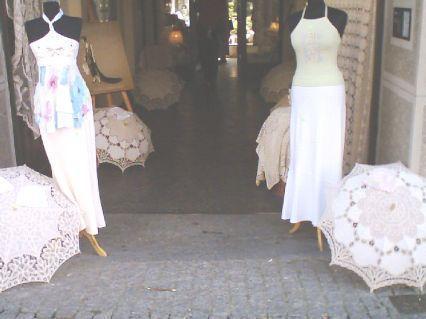How many mannequins are there?
Give a very brief answer. 2. How many umbrellas are visible?
Give a very brief answer. 3. How many people are in the photo?
Give a very brief answer. 2. How many chairs are behind the pole?
Give a very brief answer. 0. 